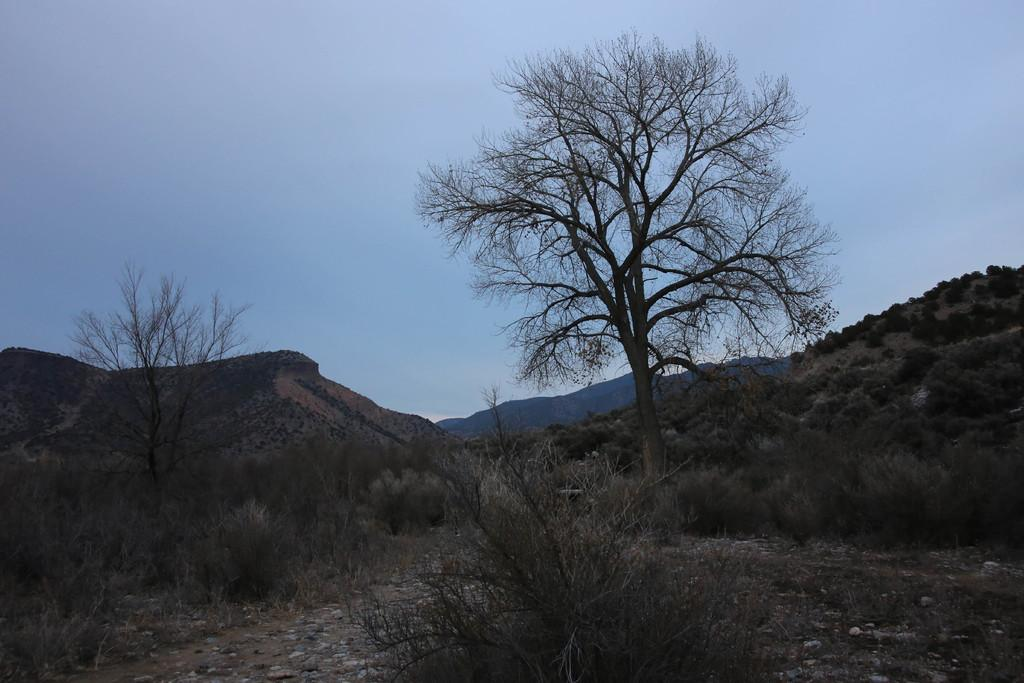What type of terrain is visible at the bottom of the image? There is sand, grass, and stones visible at the bottom of the image. What type of vegetation can be seen in the image? There are plants and trees in the image. What geographical feature is visible in the background of the image? There are mountains in the background of the image. What is visible at the top of the image? The sky is visible at the top of the image. What type of vacation is the father planning based on the image? There is no information about a vacation or a father in the image, so it cannot be determined from the image. 